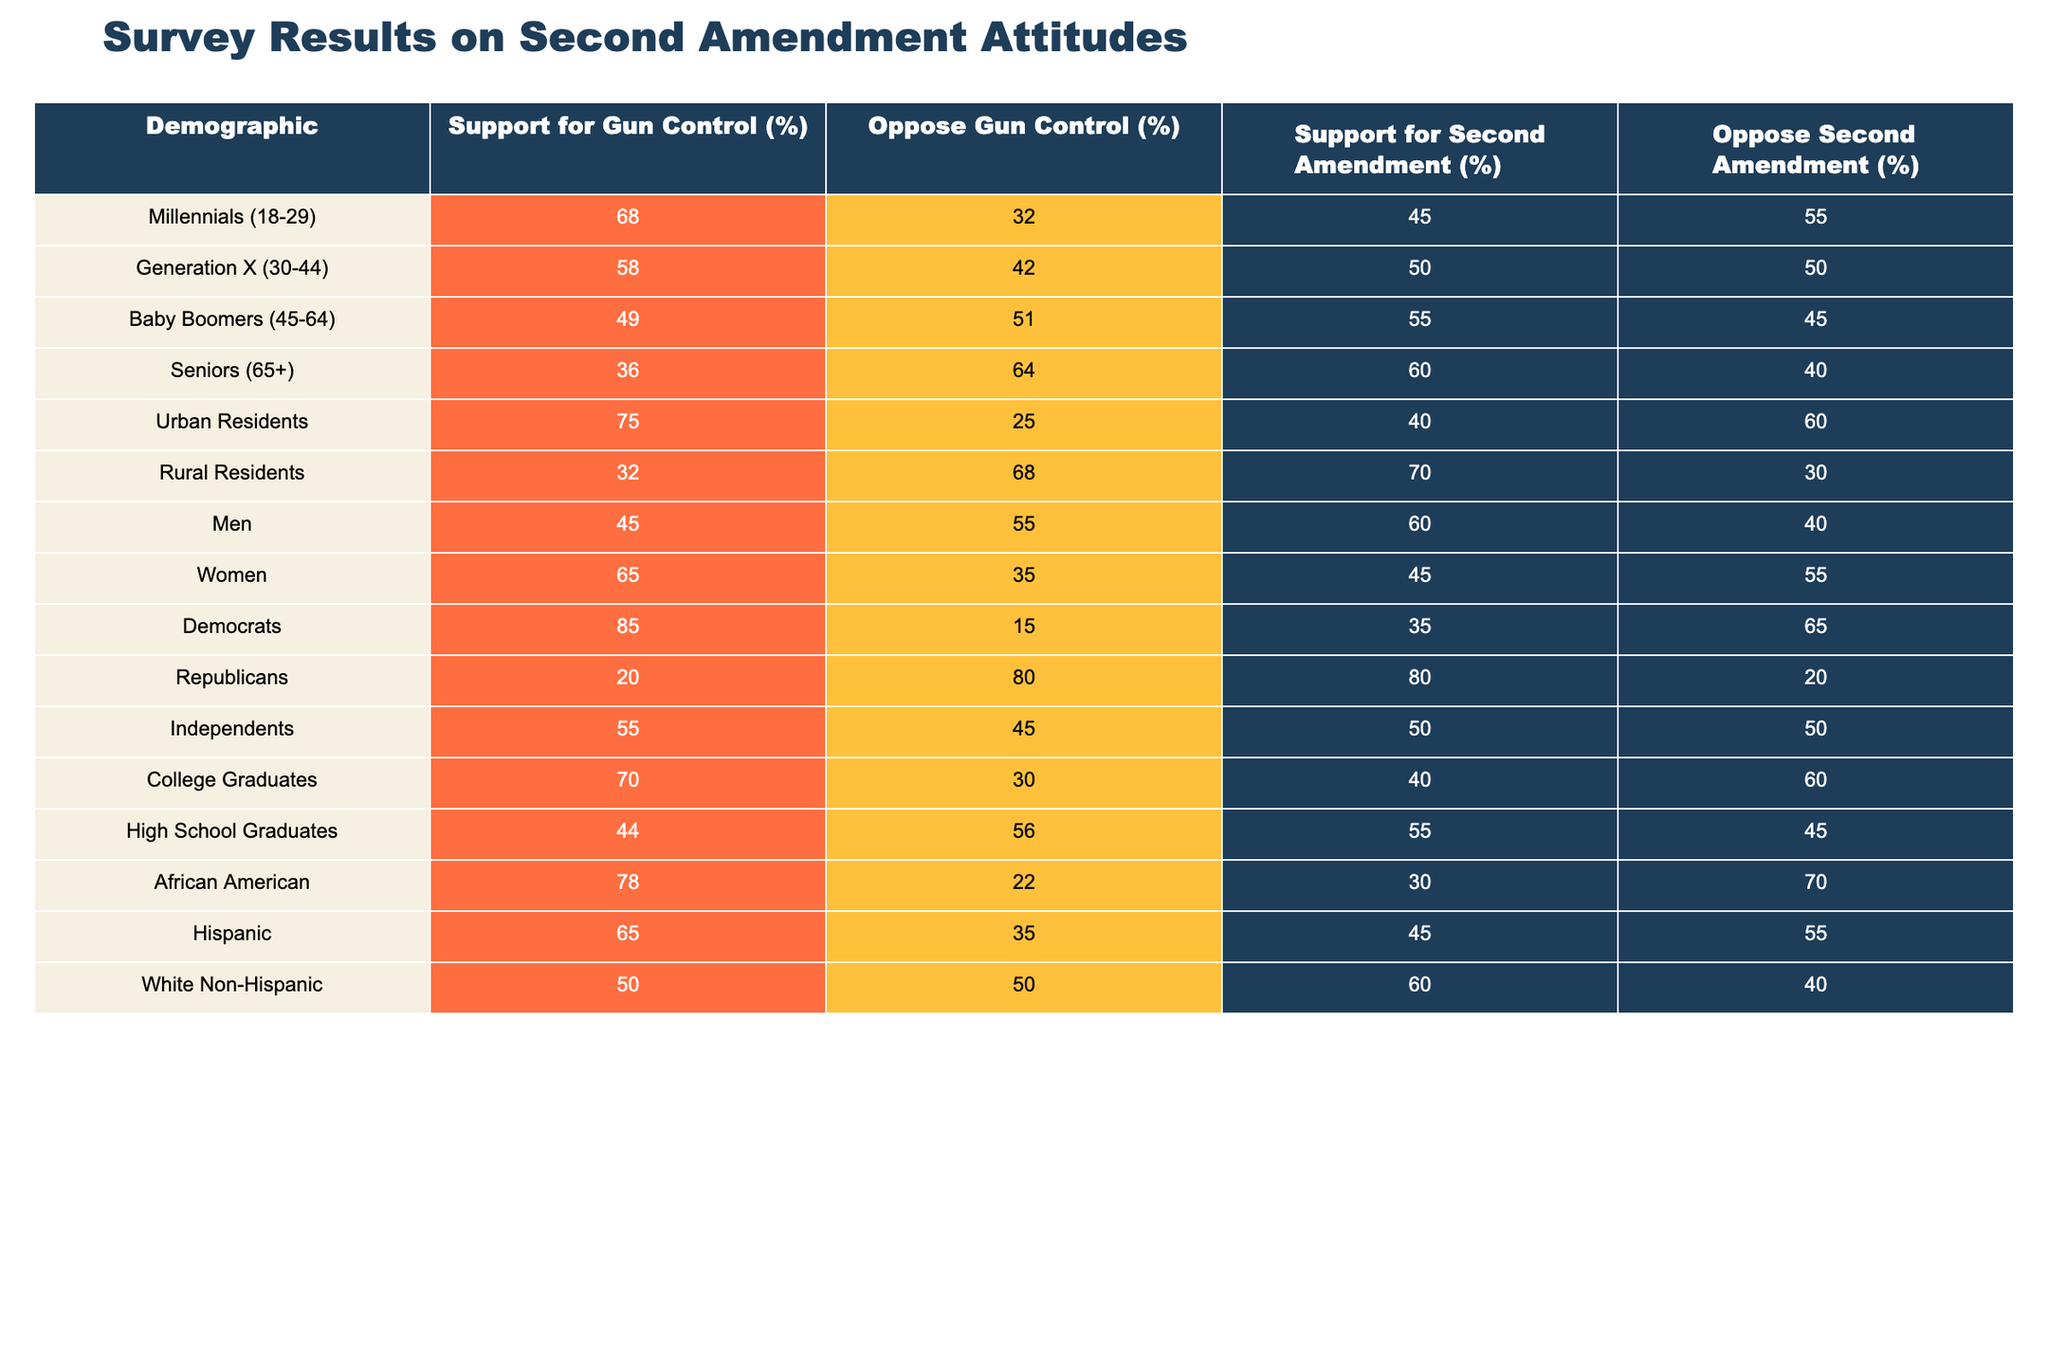What percentage of Millennials support gun control? According to the table, 68% of Millennials (ages 18-29) support gun control.
Answer: 68% Which demographic group has the highest percentage opposing gun control? Looking through the opposition percentages, Seniors (65+) have the highest at 64%.
Answer: Seniors (65+) What is the difference in percentage of support for gun control between Urban and Rural residents? Urban residents support gun control at 75%, and Rural residents at 32%. The difference is 75 - 32 = 43%.
Answer: 43% True or False: More women support gun control than oppose it. The table shows that 65% of women support gun control while 35% oppose it. Since 65% is greater than 35%, the statement is true.
Answer: True Which demographic has the highest support for the Second Amendment? Rural residents have the highest support for the Second Amendment at 70%.
Answer: Rural Residents What is the average support for gun control among all demographics listed? To calculate the average, add all support percentages: 68 + 58 + 49 + 36 + 75 + 32 + 45 + 65 + 85 + 20 + 55 + 70 + 44 + 78 + 65 + 50 = 743. There are 16 demographics, so the average is 743 / 16 = 46.4375, rounding to one decimal gives 46.4%.
Answer: 46.4% Which demographic group shows the greatest difference between support and opposition for the Second Amendment? We compare the support and opposition percentages across groups. For Republicans: 80% support, 20% oppose resulting in a difference of 60%. For Democrats: 35% support, 65% oppose leading to a difference of 30%. Rural residents have 70% support and 30% oppose with a difference of 40%. The greatest difference is with Republicans at 60%.
Answer: Republicans What percentage of Independents oppose the Second Amendment? The table indicates that 50% of Independents oppose the Second Amendment.
Answer: 50% Which demographic has a more significant support for gun control, Hispanics or African Americans? Hispanics support gun control at 65%, while African Americans support it at 78%. Since 78% is greater than 65%, African Americans have more support.
Answer: African Americans What is the combined percentage of support for the Second Amendment among Baby Boomers and Independents? Baby Boomers support the Second Amendment at 55%, and Independents support it at 50%. The combined percentage is 55 + 50 = 105%.
Answer: 105% Is it true that college graduates are more likely to support the Second Amendment than Millennials? College Graduates support the Second Amendment at 40%, while Millennials support it at 45%. Since 40% is less than 45%, the statement is false.
Answer: False 